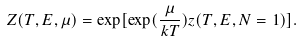Convert formula to latex. <formula><loc_0><loc_0><loc_500><loc_500>Z ( T , E , \mu ) = \exp [ \exp ( \frac { \mu } { k T } ) z ( T , E , N = 1 ) ] .</formula> 